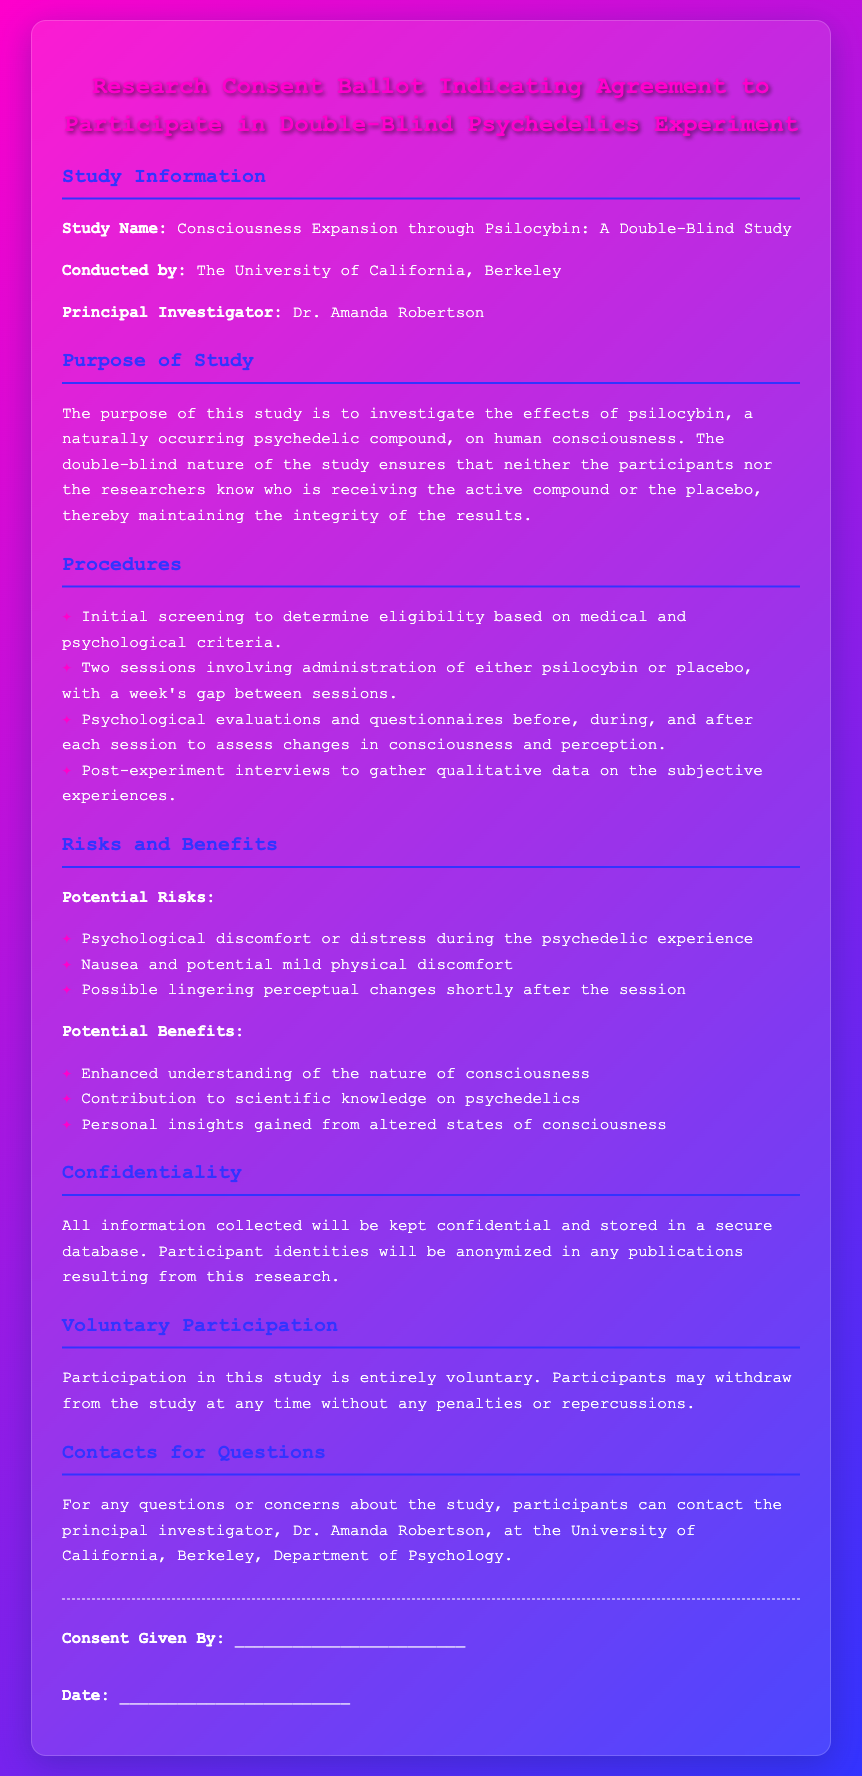What is the study name? The study name is clearly mentioned in the "Study Information" section of the document.
Answer: Consciousness Expansion through Psilocybin: A Double-Blind Study Who is the principal investigator? The principal investigator's name is provided under the "Study Information" section of the document.
Answer: Dr. Amanda Robertson What are the potential risks listed? The risks are outlined in the "Risks and Benefits" section, specifying the possible adverse effects.
Answer: Psychological discomfort or distress; Nausea; Possible lingering perceptual changes What is the purpose of the study? The purpose is stated in the "Purpose of Study" section and provides insight into the study's aims.
Answer: To investigate the effects of psilocybin on human consciousness How many sessions will there be? The number of sessions is indicated in the "Procedures" section of the document.
Answer: Two sessions Is participation voluntary? The document specifies that participation is voluntary in the "Voluntary Participation" section.
Answer: Yes What organization is conducting the study? The conducting organization is mentioned in the "Study Information" section.
Answer: The University of California, Berkeley What will participants need to do before the sessions? The specific actions required prior to the sessions are outlined in the "Procedures" section.
Answer: Initial screening What should participants do if they have questions? The document provides contact information for participants to address their questions.
Answer: Contact Dr. Amanda Robertson 